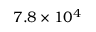Convert formula to latex. <formula><loc_0><loc_0><loc_500><loc_500>7 . 8 \times 1 0 ^ { 4 }</formula> 